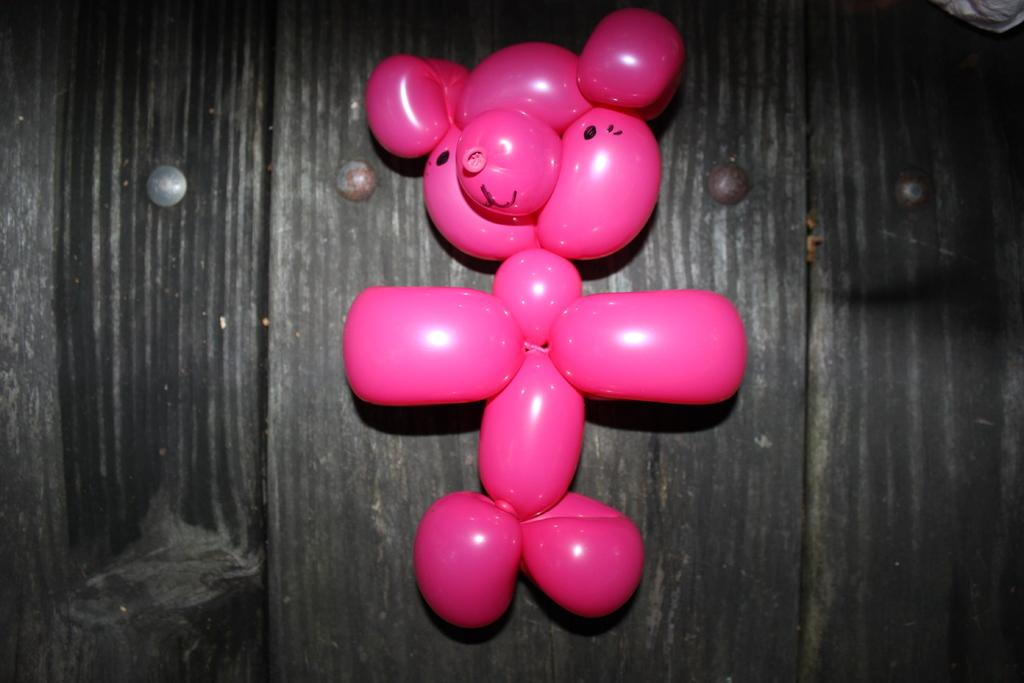What type of material is the wall made of in the image? There is a wooden wall in the image. What object can be seen on the wall in the image? There is a balloon toy on the wall in the image. What type of land is visible in the image? There is no land visible in the image, as it only features a wooden wall and a balloon toy. How many men are present in the image? There are no men present in the image. 